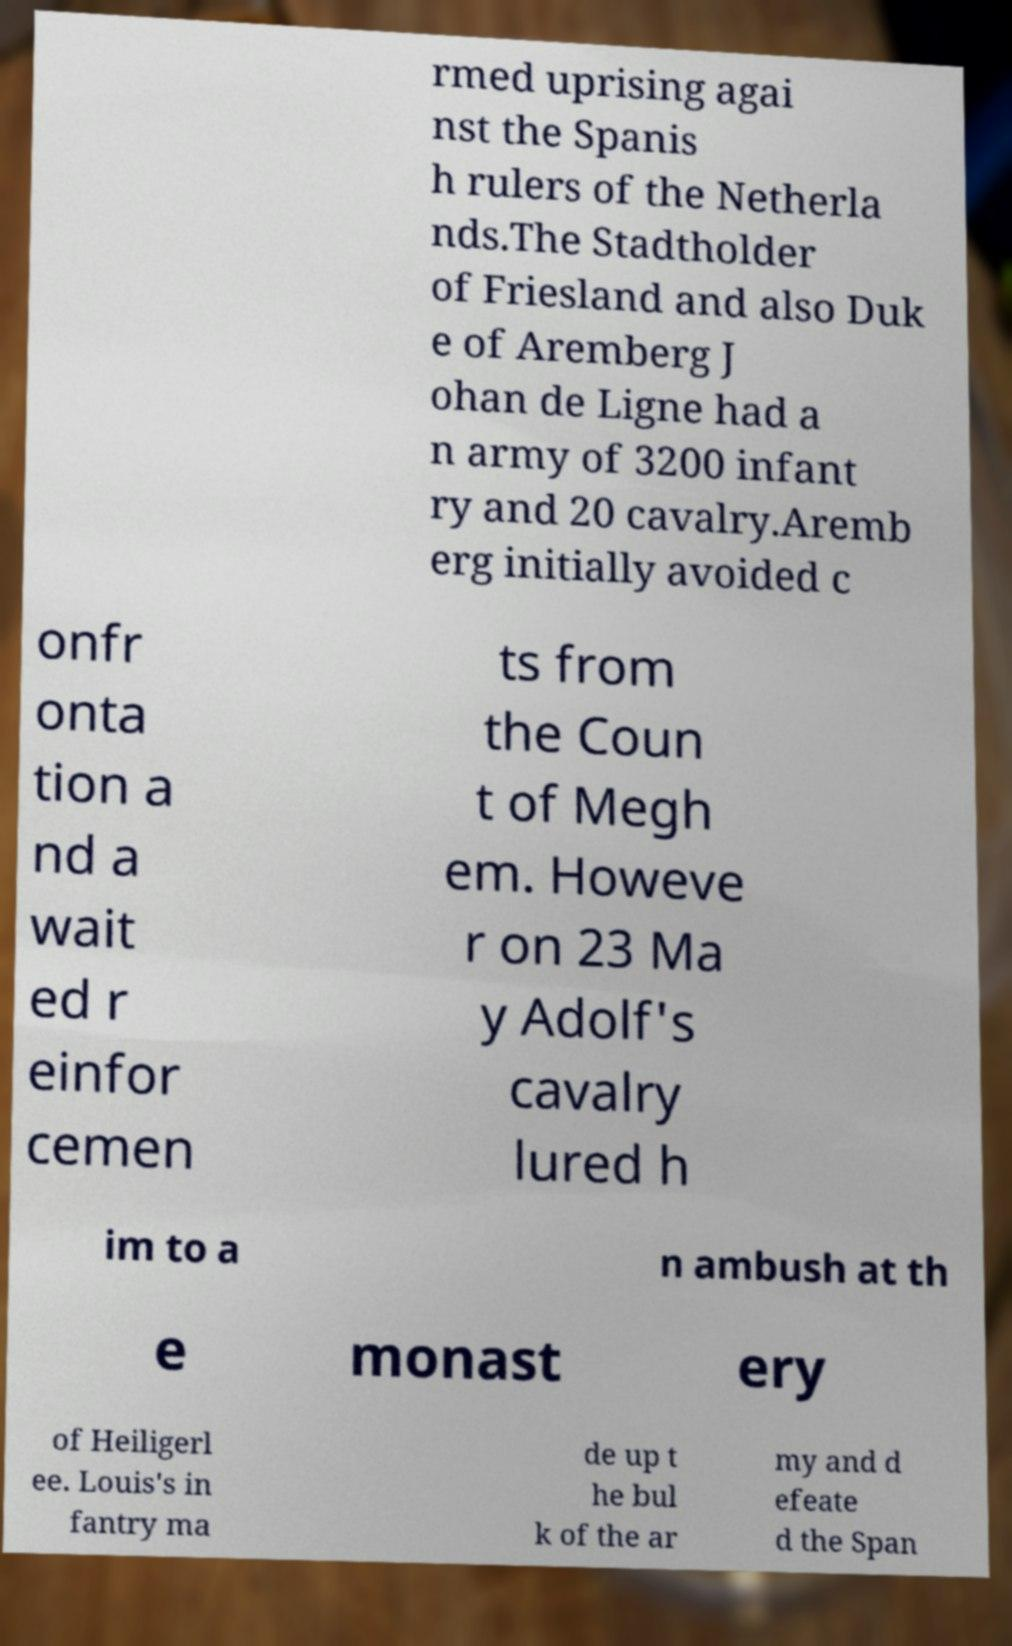Could you extract and type out the text from this image? rmed uprising agai nst the Spanis h rulers of the Netherla nds.The Stadtholder of Friesland and also Duk e of Aremberg J ohan de Ligne had a n army of 3200 infant ry and 20 cavalry.Aremb erg initially avoided c onfr onta tion a nd a wait ed r einfor cemen ts from the Coun t of Megh em. Howeve r on 23 Ma y Adolf's cavalry lured h im to a n ambush at th e monast ery of Heiligerl ee. Louis's in fantry ma de up t he bul k of the ar my and d efeate d the Span 